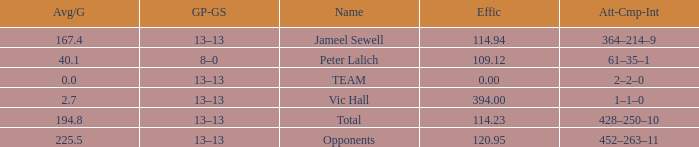Write the full table. {'header': ['Avg/G', 'GP-GS', 'Name', 'Effic', 'Att-Cmp-Int'], 'rows': [['167.4', '13–13', 'Jameel Sewell', '114.94', '364–214–9'], ['40.1', '8–0', 'Peter Lalich', '109.12', '61–35–1'], ['0.0', '13–13', 'TEAM', '0.00', '2–2–0'], ['2.7', '13–13', 'Vic Hall', '394.00', '1–1–0'], ['194.8', '13–13', 'Total', '114.23', '428–250–10'], ['225.5', '13–13', 'Opponents', '120.95', '452–263–11']]} Avg/G that has a GP-GS of 13–13, and a Effic smaller than 114.23 has what total of numbers? 1.0. 